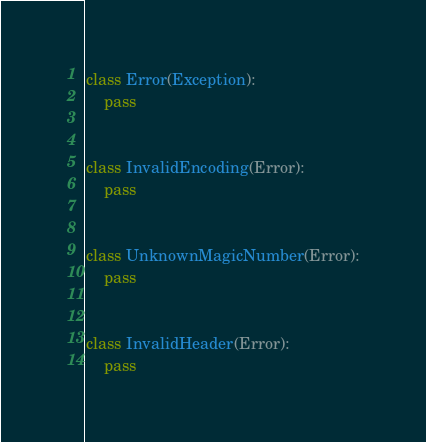Convert code to text. <code><loc_0><loc_0><loc_500><loc_500><_Python_>
class Error(Exception):
    pass


class InvalidEncoding(Error):
    pass


class UnknownMagicNumber(Error):
    pass


class InvalidHeader(Error):
    pass
</code> 